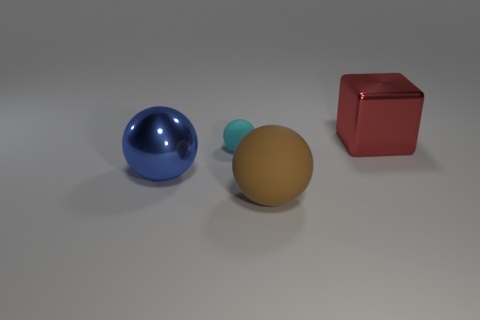Is the small matte object the same color as the large matte sphere?
Your answer should be very brief. No. Is there anything else that is the same color as the large metal ball?
Your answer should be compact. No. How many tiny cyan matte objects are behind the sphere behind the big ball that is to the left of the large brown object?
Provide a succinct answer. 0. What number of big red things are there?
Ensure brevity in your answer.  1. Is the number of large metallic cubes on the left side of the small rubber thing less than the number of metallic blocks on the right side of the brown ball?
Your answer should be very brief. Yes. Are there fewer big metallic balls that are behind the big red metallic block than big brown rubber balls?
Offer a terse response. Yes. What material is the large sphere that is to the right of the rubber object that is behind the large blue shiny thing that is in front of the small cyan sphere?
Make the answer very short. Rubber. How many objects are either shiny objects that are left of the big red block or shiny things in front of the red block?
Offer a very short reply. 1. What is the material of the large blue object that is the same shape as the brown rubber thing?
Make the answer very short. Metal. What number of rubber things are big blocks or large blue things?
Your answer should be very brief. 0. 